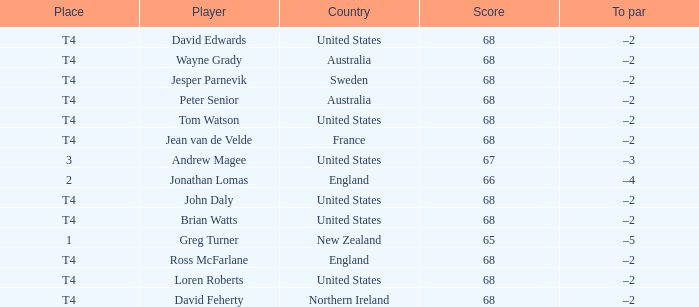Name the Score united states of tom watson in united state? 68.0. 